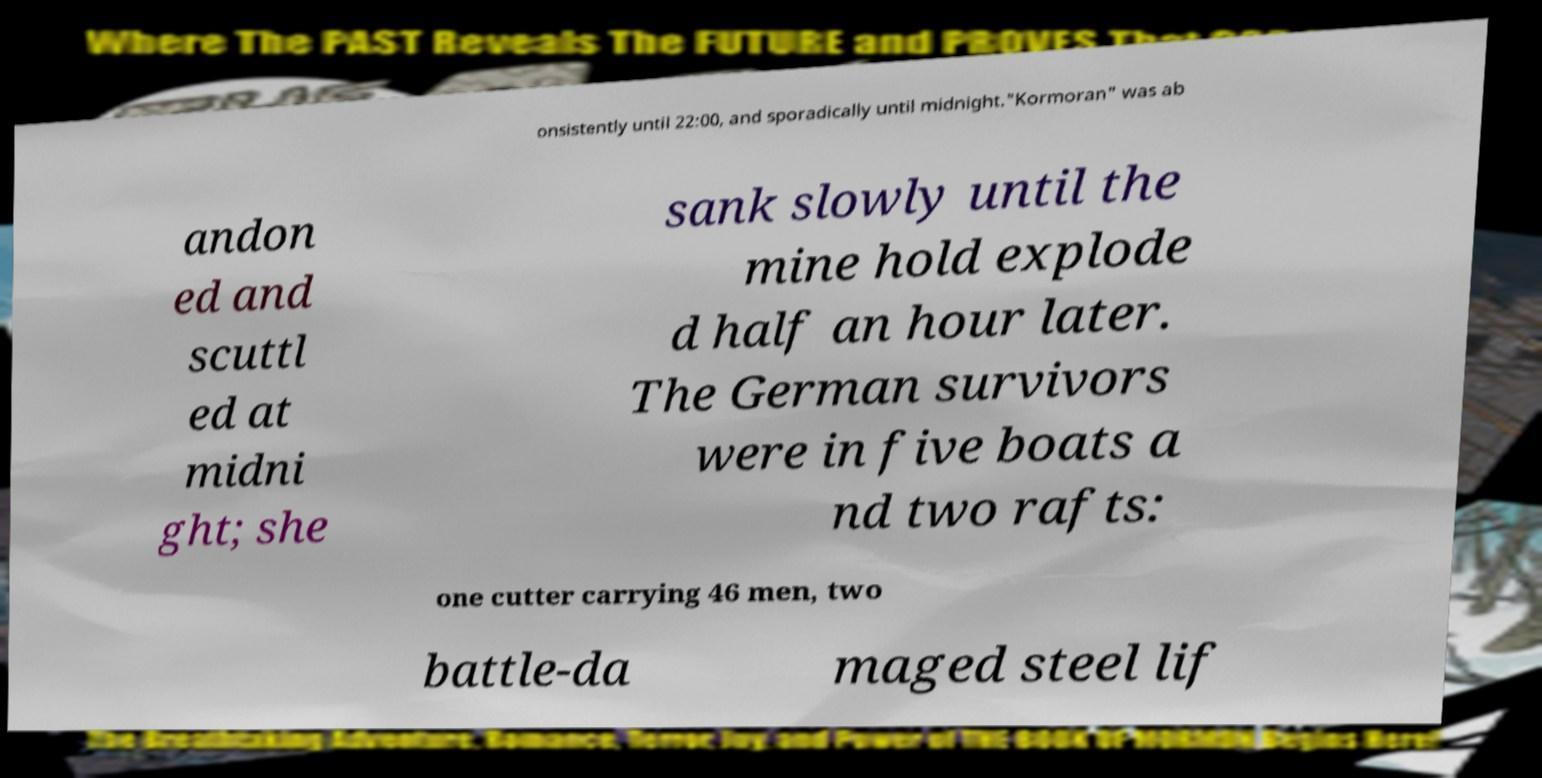Please read and relay the text visible in this image. What does it say? onsistently until 22:00, and sporadically until midnight."Kormoran" was ab andon ed and scuttl ed at midni ght; she sank slowly until the mine hold explode d half an hour later. The German survivors were in five boats a nd two rafts: one cutter carrying 46 men, two battle-da maged steel lif 